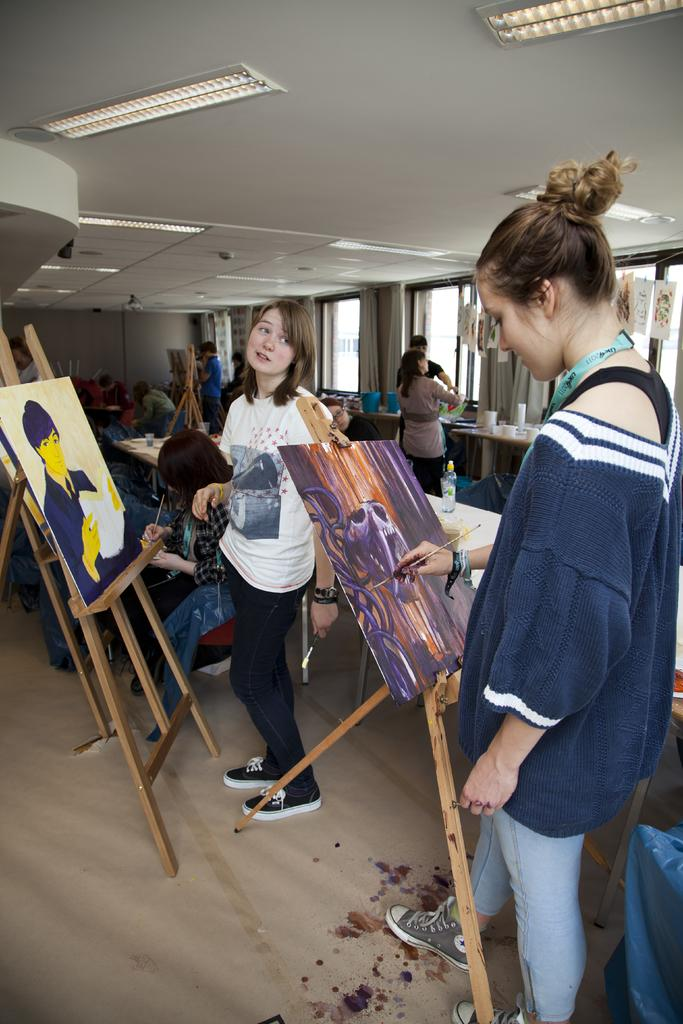How many women are in the image? There are two women in the image. What are the women doing in the image? The women are painting with canvas. Where are the women positioned in relation to the canvas? The women are standing in front of the canvas. Are there any other people present in the image? Yes, there are other people present in the image. What type of coat is being used to fold the pies in the image? There are no coats or pies present in the image; it features two women painting with canvas and other people. 